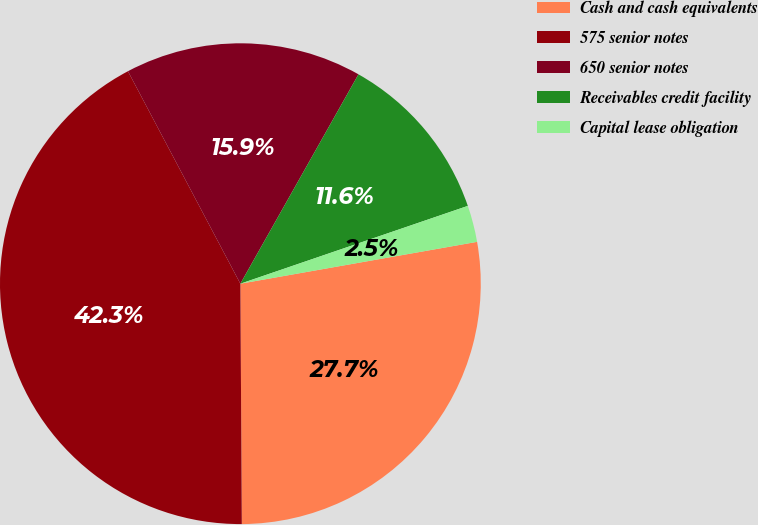Convert chart. <chart><loc_0><loc_0><loc_500><loc_500><pie_chart><fcel>Cash and cash equivalents<fcel>575 senior notes<fcel>650 senior notes<fcel>Receivables credit facility<fcel>Capital lease obligation<nl><fcel>27.69%<fcel>42.35%<fcel>15.92%<fcel>11.58%<fcel>2.46%<nl></chart> 